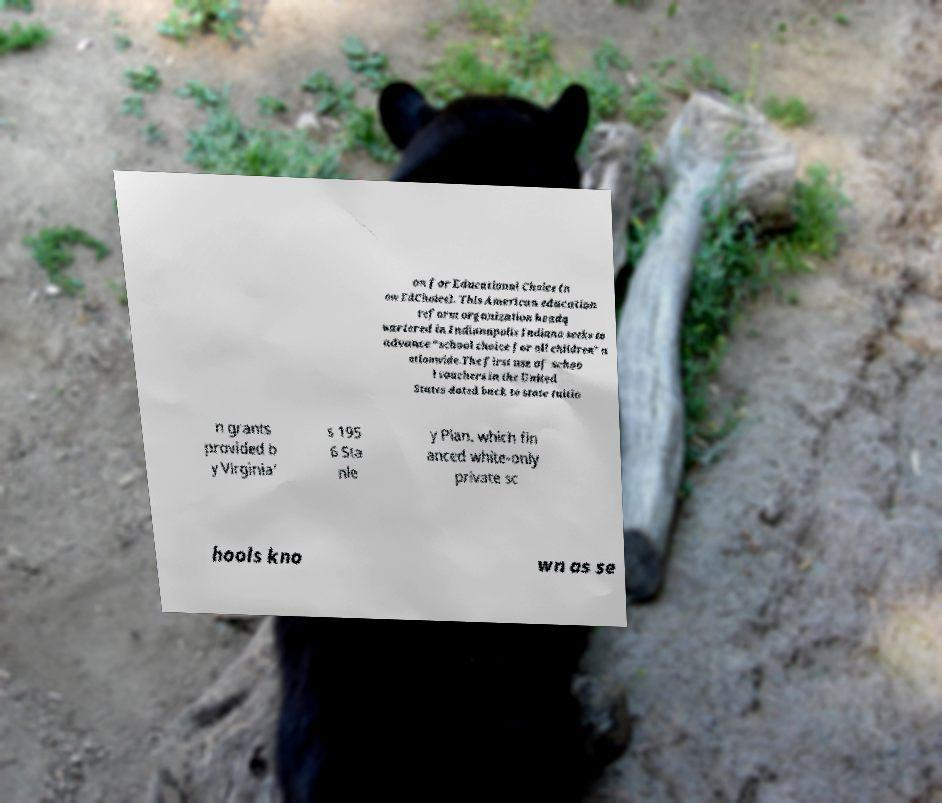There's text embedded in this image that I need extracted. Can you transcribe it verbatim? on for Educational Choice (n ow EdChoice). This American education reform organization headq uartered in Indianapolis Indiana seeks to advance “school choice for all children” n ationwide.The first use of schoo l vouchers in the United States dated back to state tuitio n grants provided b y Virginia' s 195 6 Sta nle y Plan, which fin anced white-only private sc hools kno wn as se 